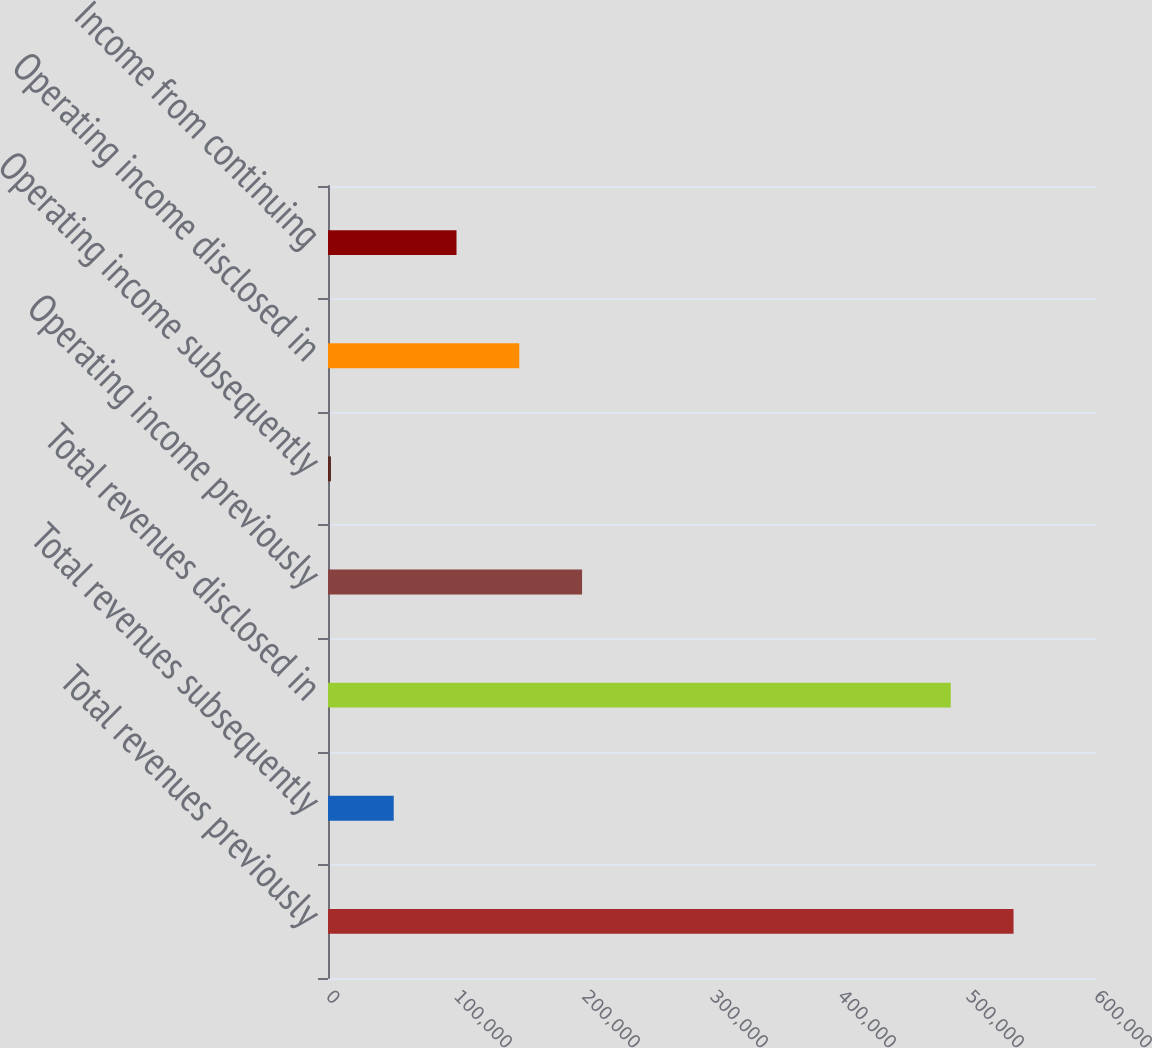<chart> <loc_0><loc_0><loc_500><loc_500><bar_chart><fcel>Total revenues previously<fcel>Total revenues subsequently<fcel>Total revenues disclosed in<fcel>Operating income previously<fcel>Operating income subsequently<fcel>Operating income disclosed in<fcel>Income from continuing<nl><fcel>535578<fcel>51343.9<fcel>486532<fcel>198482<fcel>2298<fcel>149436<fcel>100390<nl></chart> 